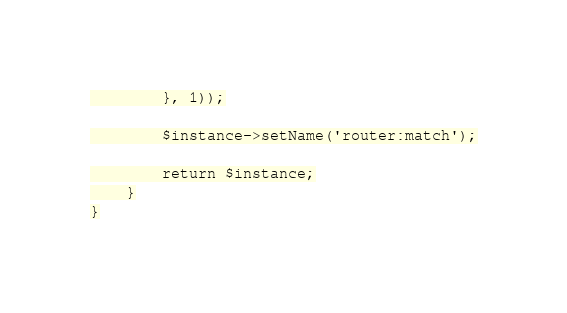Convert code to text. <code><loc_0><loc_0><loc_500><loc_500><_PHP_>        }, 1));

        $instance->setName('router:match');

        return $instance;
    }
}
</code> 